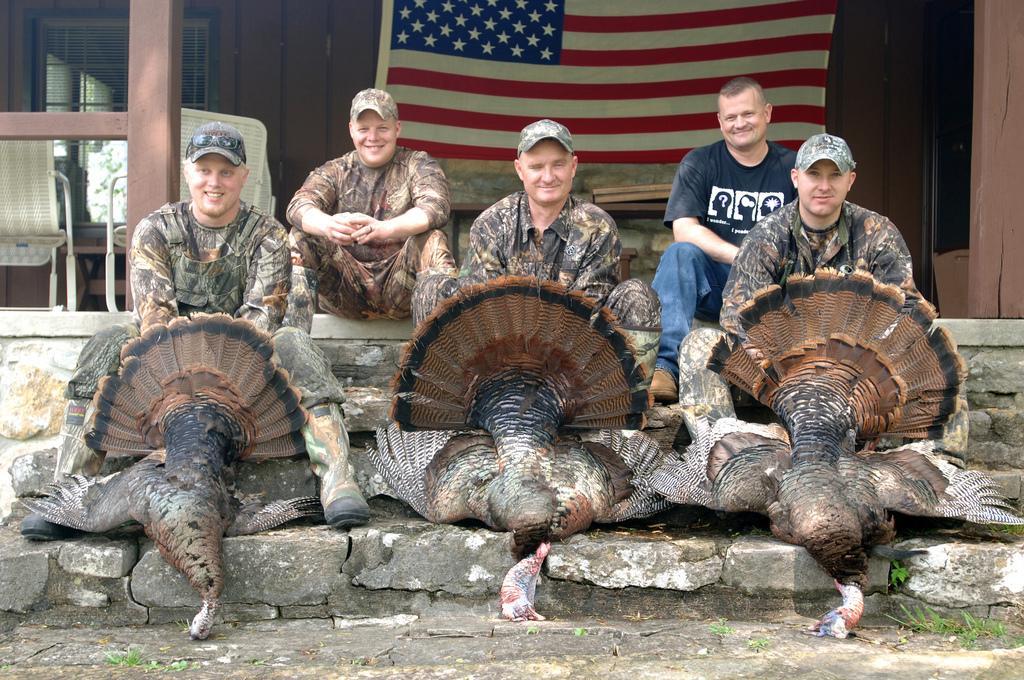Can you describe this image briefly? In this image we can see some people sitting and among them few people wearing uniform and there are three birds in front of them. In the background, we can see a building and there is a flag and we can see two chairs and some other objects. 